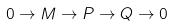Convert formula to latex. <formula><loc_0><loc_0><loc_500><loc_500>0 \to M \to P \to Q \to 0</formula> 